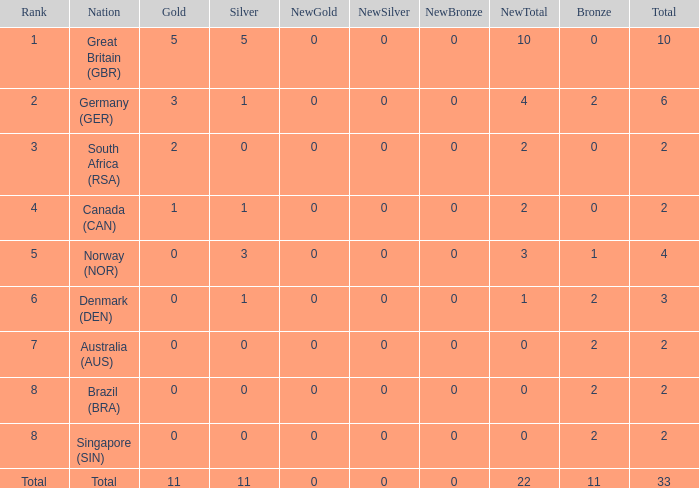What is bronze when the rank is 3 and the total is more than 2? None. 